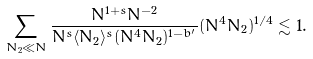Convert formula to latex. <formula><loc_0><loc_0><loc_500><loc_500>\sum _ { N _ { 2 } \ll N } \frac { N ^ { 1 + s } N ^ { - 2 } } { N ^ { s } \langle N _ { 2 } \rangle ^ { s } ( N ^ { 4 } N _ { 2 } ) ^ { 1 - b ^ { \prime } } } ( N ^ { 4 } N _ { 2 } ) ^ { 1 / 4 } \lesssim 1 .</formula> 